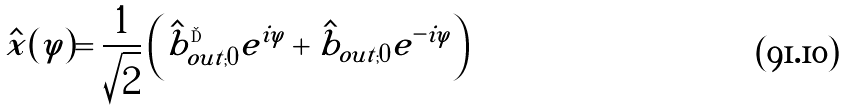<formula> <loc_0><loc_0><loc_500><loc_500>\hat { x } ( \varphi ) = \frac { 1 } { \sqrt { 2 } } \left ( \hat { b } _ { o u t ; 0 } ^ { \dag } e ^ { i \varphi } + \hat { b } _ { o u t ; 0 } e ^ { - i \varphi } \right )</formula> 